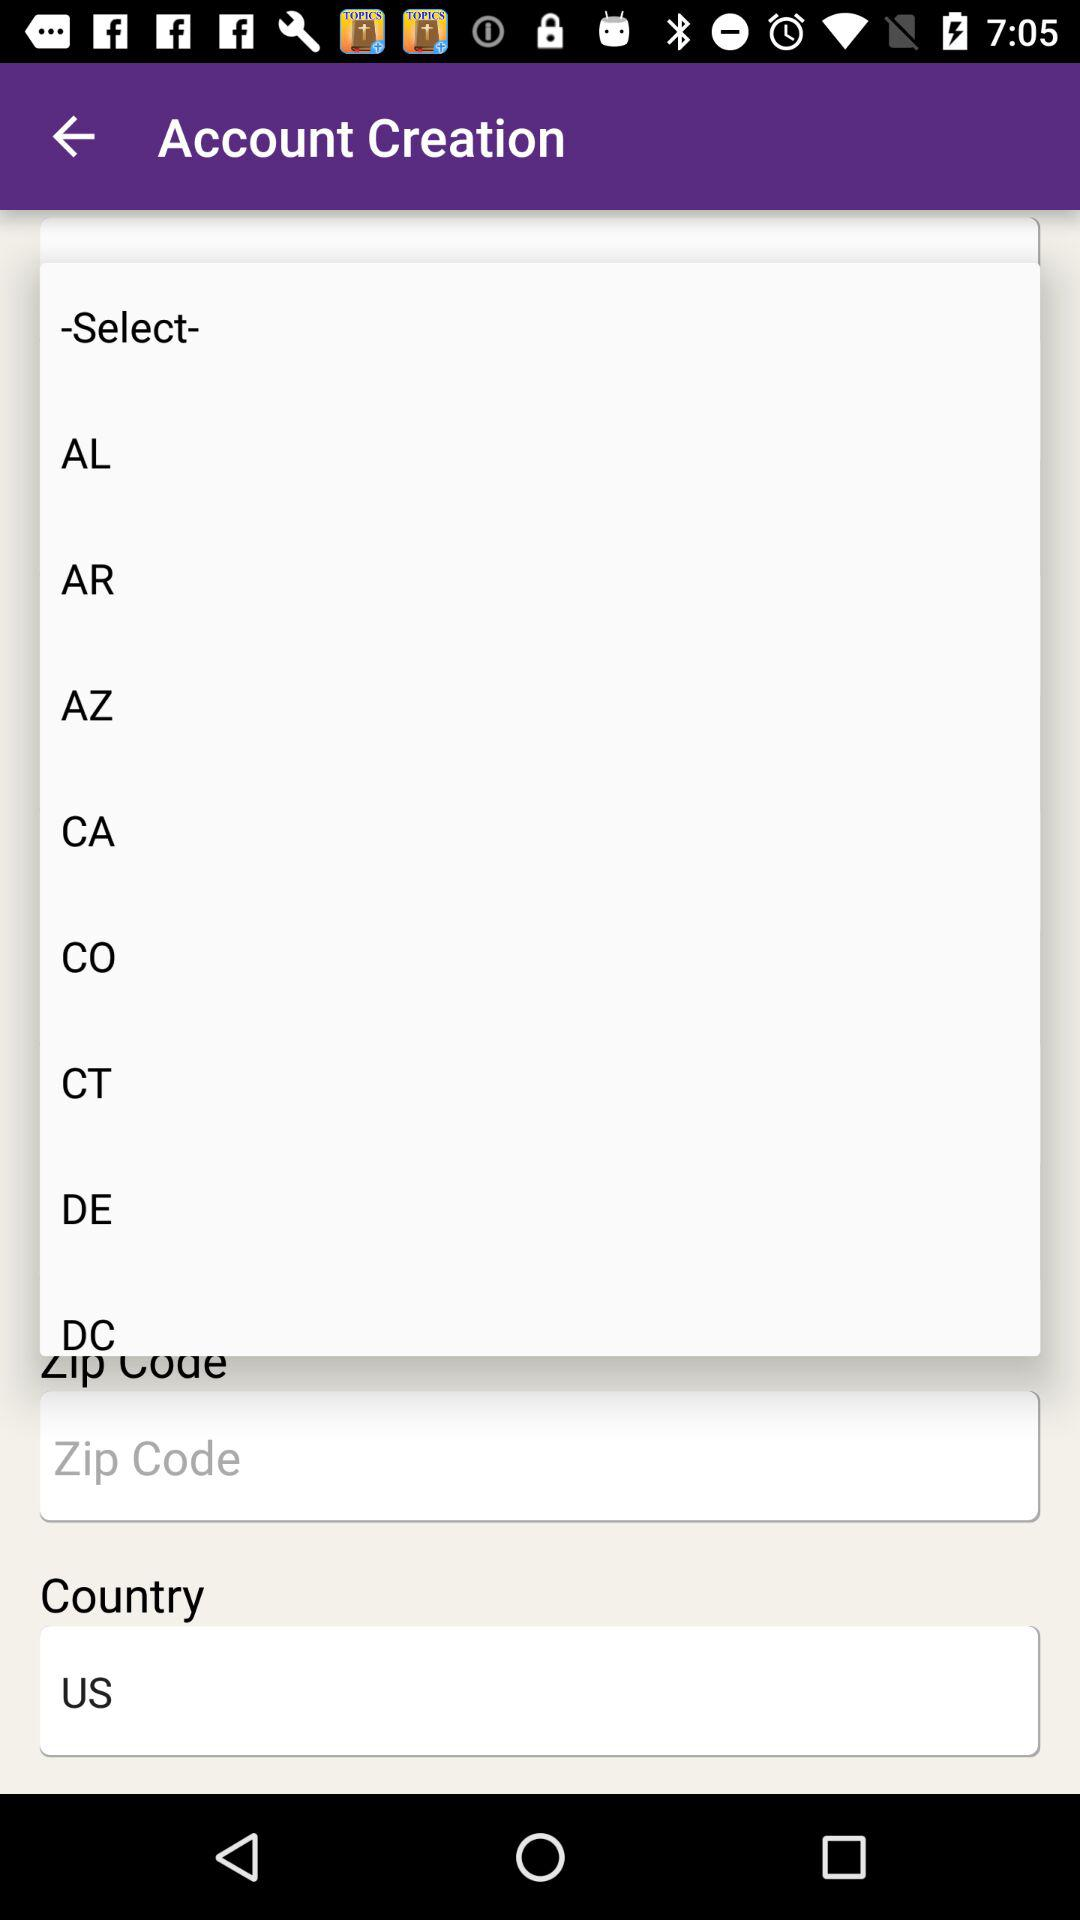What is the selected country? The selected country is the United States. 